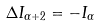Convert formula to latex. <formula><loc_0><loc_0><loc_500><loc_500>\Delta I _ { \alpha + 2 } = - I _ { \alpha }</formula> 